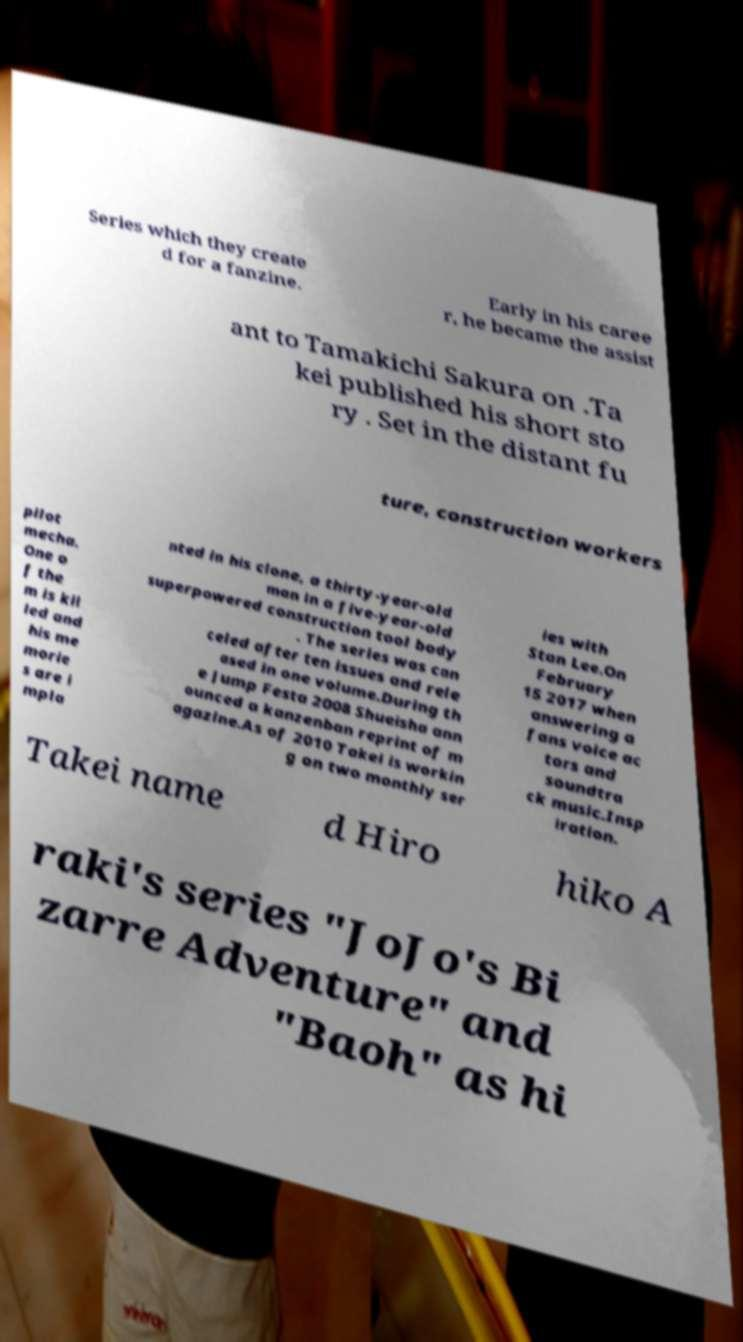Please read and relay the text visible in this image. What does it say? Series which they create d for a fanzine. Early in his caree r, he became the assist ant to Tamakichi Sakura on .Ta kei published his short sto ry . Set in the distant fu ture, construction workers pilot mecha. One o f the m is kil led and his me morie s are i mpla nted in his clone, a thirty-year-old man in a five-year-old superpowered construction tool body . The series was can celed after ten issues and rele ased in one volume.During th e Jump Festa 2008 Shueisha ann ounced a kanzenban reprint of m agazine.As of 2010 Takei is workin g on two monthly ser ies with Stan Lee.On February 15 2017 when answering a fans voice ac tors and soundtra ck music.Insp iration. Takei name d Hiro hiko A raki's series "JoJo's Bi zarre Adventure" and "Baoh" as hi 